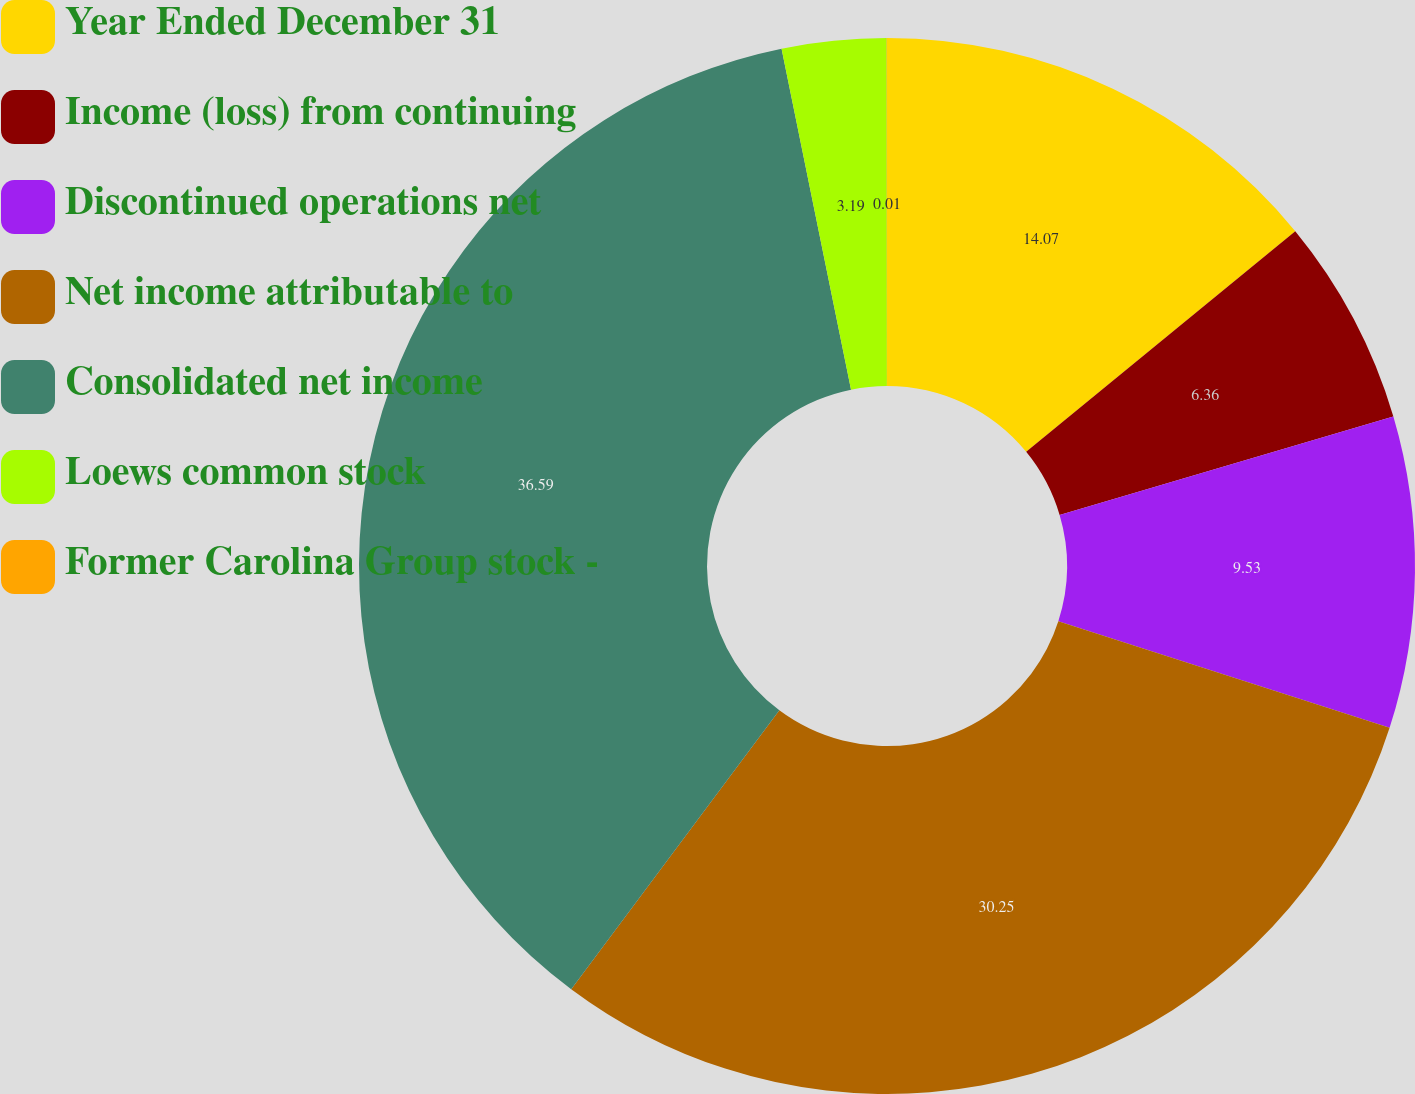Convert chart. <chart><loc_0><loc_0><loc_500><loc_500><pie_chart><fcel>Year Ended December 31<fcel>Income (loss) from continuing<fcel>Discontinued operations net<fcel>Net income attributable to<fcel>Consolidated net income<fcel>Loews common stock<fcel>Former Carolina Group stock -<nl><fcel>14.07%<fcel>6.36%<fcel>9.53%<fcel>30.25%<fcel>36.6%<fcel>3.19%<fcel>0.01%<nl></chart> 